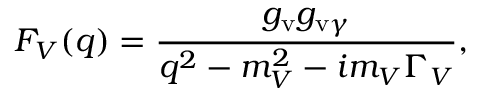Convert formula to latex. <formula><loc_0><loc_0><loc_500><loc_500>F _ { V } ( q ) = { \frac { g _ { v } g _ { v \gamma } } { q ^ { 2 } - m _ { V } ^ { 2 } - i m _ { V } \Gamma _ { V } } } ,</formula> 